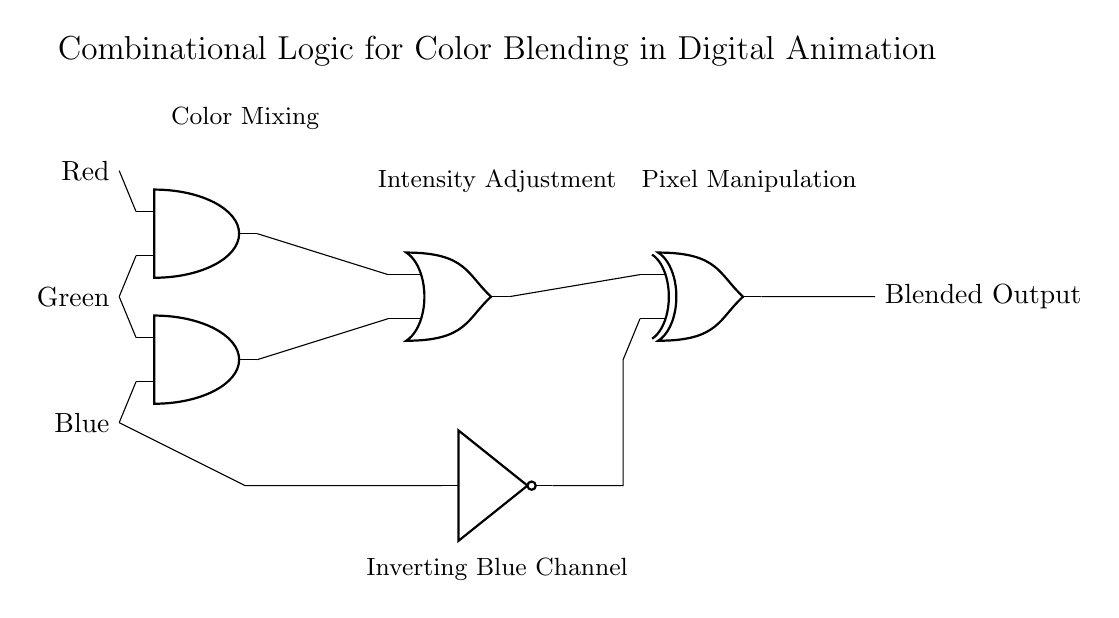What are the input signals in the circuit? The input signals are Red, Green, and Blue, which are represented on the left side of the circuit diagram.
Answer: Red, Green, Blue What type of logic gates are used in this circuit? The circuit contains AND gates, an OR gate, a XOR gate, and a NOT gate. Each gate type is indicated by its symbol in the diagram.
Answer: AND, OR, XOR, NOT Which gate is used to invert the Blue channel? The NOT gate is used specifically to invert the input from the Blue channel, as shown by the line connecting it to the output of the Blue input.
Answer: NOT gate What is the final output of the circuit? The final output from the circuit is labeled as Blended Output, indicating the result after processing the input signals through the logic gates.
Answer: Blended Output How many AND gates are present in the circuit? The circuit contains two AND gates, as indicated by the distinct AND gate symbols in the schematic.
Answer: Two What is the purpose of the OR gate in this circuit? The OR gate combines the outputs of the two AND gates, allowing for a broader range of signal combinations to contribute to the final output.
Answer: Combine outputs How does the XOR gate contribute to pixel manipulation? The XOR gate takes the output from the OR gate and the modified Blue signal (after being inverted by the NOT gate), allowing specific conditions of pixel blending based on different input states.
Answer: Enables specific blending conditions 